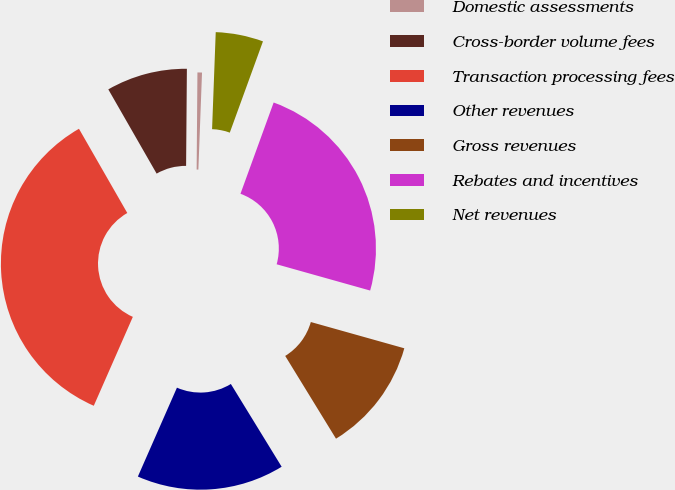Convert chart. <chart><loc_0><loc_0><loc_500><loc_500><pie_chart><fcel>Domestic assessments<fcel>Cross-border volume fees<fcel>Transaction processing fees<fcel>Other revenues<fcel>Gross revenues<fcel>Rebates and incentives<fcel>Net revenues<nl><fcel>0.47%<fcel>8.42%<fcel>35.12%<fcel>15.35%<fcel>11.88%<fcel>23.81%<fcel>4.95%<nl></chart> 